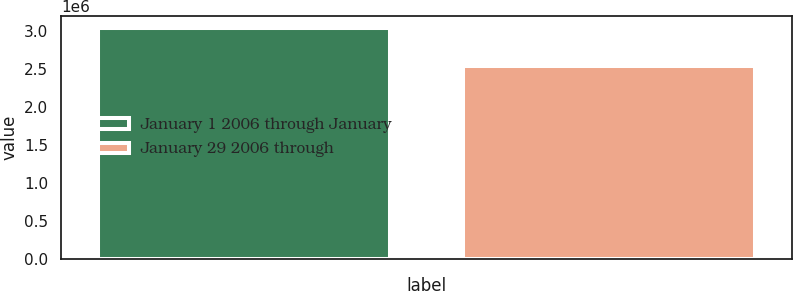Convert chart. <chart><loc_0><loc_0><loc_500><loc_500><bar_chart><fcel>January 1 2006 through January<fcel>January 29 2006 through<nl><fcel>3.04973e+06<fcel>2.54075e+06<nl></chart> 